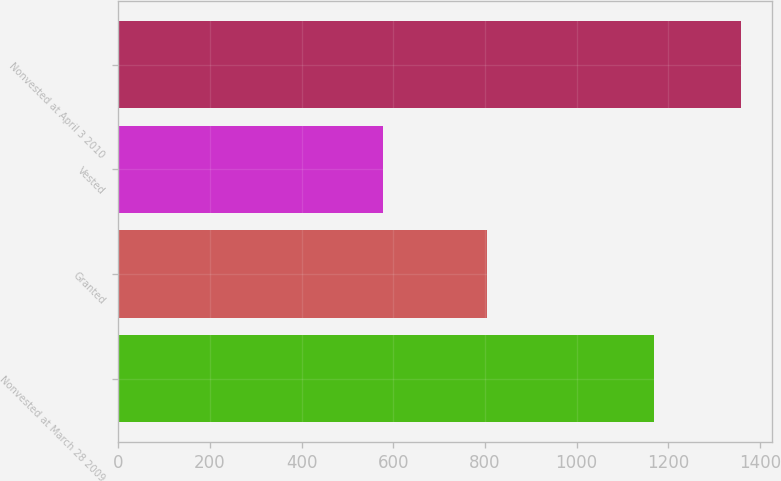<chart> <loc_0><loc_0><loc_500><loc_500><bar_chart><fcel>Nonvested at March 28 2009<fcel>Granted<fcel>Vested<fcel>Nonvested at April 3 2010<nl><fcel>1168<fcel>805<fcel>578<fcel>1359<nl></chart> 